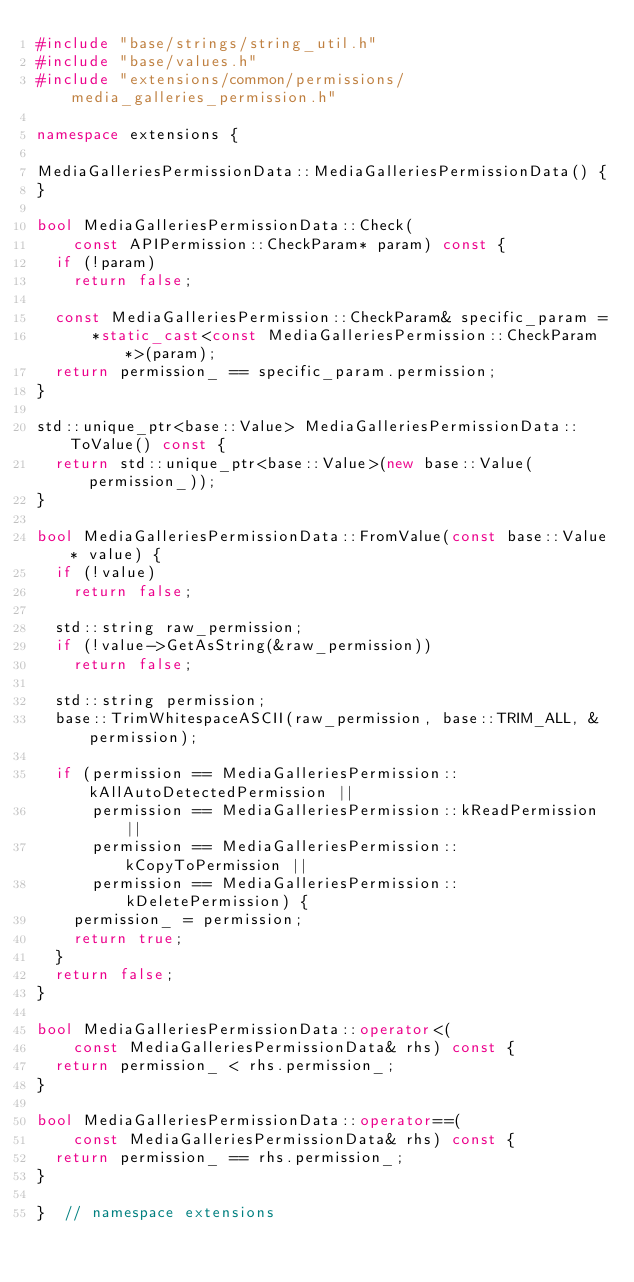<code> <loc_0><loc_0><loc_500><loc_500><_C++_>#include "base/strings/string_util.h"
#include "base/values.h"
#include "extensions/common/permissions/media_galleries_permission.h"

namespace extensions {

MediaGalleriesPermissionData::MediaGalleriesPermissionData() {
}

bool MediaGalleriesPermissionData::Check(
    const APIPermission::CheckParam* param) const {
  if (!param)
    return false;

  const MediaGalleriesPermission::CheckParam& specific_param =
      *static_cast<const MediaGalleriesPermission::CheckParam*>(param);
  return permission_ == specific_param.permission;
}

std::unique_ptr<base::Value> MediaGalleriesPermissionData::ToValue() const {
  return std::unique_ptr<base::Value>(new base::Value(permission_));
}

bool MediaGalleriesPermissionData::FromValue(const base::Value* value) {
  if (!value)
    return false;

  std::string raw_permission;
  if (!value->GetAsString(&raw_permission))
    return false;

  std::string permission;
  base::TrimWhitespaceASCII(raw_permission, base::TRIM_ALL, &permission);

  if (permission == MediaGalleriesPermission::kAllAutoDetectedPermission ||
      permission == MediaGalleriesPermission::kReadPermission ||
      permission == MediaGalleriesPermission::kCopyToPermission ||
      permission == MediaGalleriesPermission::kDeletePermission) {
    permission_ = permission;
    return true;
  }
  return false;
}

bool MediaGalleriesPermissionData::operator<(
    const MediaGalleriesPermissionData& rhs) const {
  return permission_ < rhs.permission_;
}

bool MediaGalleriesPermissionData::operator==(
    const MediaGalleriesPermissionData& rhs) const {
  return permission_ == rhs.permission_;
}

}  // namespace extensions
</code> 